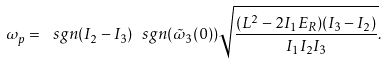Convert formula to latex. <formula><loc_0><loc_0><loc_500><loc_500>\omega _ { p } = \ s g n ( I _ { 2 } - I _ { 3 } ) \ s g n ( \tilde { \omega } _ { 3 } ( 0 ) ) \sqrt { \frac { ( L ^ { 2 } - 2 I _ { 1 } E _ { R } ) ( I _ { 3 } - I _ { 2 } ) } { I _ { 1 } I _ { 2 } I _ { 3 } } } .</formula> 